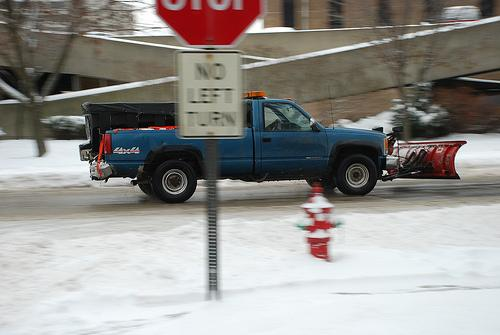Describe the location and appearance of the tree in the image. There is a brown, leafless tree growing next to the sidewalk at the left-top corner of the image. What is the detectable sign on the back of the blue truck? There are black bands detectable on the back of the blue truck. List two visible traffic signs shown in the image. There is a red stop sign and a black-and-white no left turn sign at the side of the road. What color is the truck and what is it doing? The truck is blue and it's traveling down the street with a red snow plow attached to it. Express the sentiment of the image using adjectives and nouns. Wintry, snowy, chilly, urban street, blue truck, red fire hydrant, traffic signs. Mention any specific details regarding lights on the blue truck. There are orange lights on the roof of the blue truck and red tail light noticeable as well. Can you please describe the situation with the fire hydrant in this image? There is a red fire hydrant on the sidewalk, which appears to be partially covered in white snow. Provide a short description of the scene in the given image. The image features a blue pick-up truck with a red snow plow driving down a snow-covered street, with traffic signs and a red fire hydrant nearby. Are there any indications of the season or weather conditions in this image? Yes, there are indications of a winter snowstorm that has covered the area including snow on the ground, snow-packed on the side of the street, and snow accumulated on bushes. 